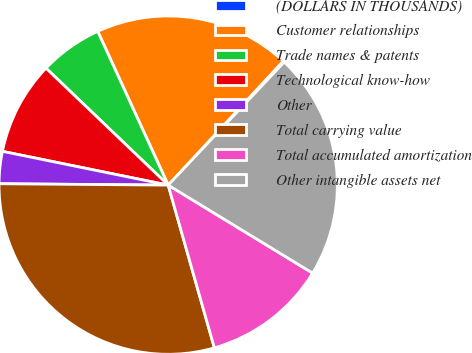Convert chart to OTSL. <chart><loc_0><loc_0><loc_500><loc_500><pie_chart><fcel>(DOLLARS IN THOUSANDS)<fcel>Customer relationships<fcel>Trade names & patents<fcel>Technological know-how<fcel>Other<fcel>Total carrying value<fcel>Total accumulated amortization<fcel>Other intangible assets net<nl><fcel>0.13%<fcel>18.74%<fcel>6.01%<fcel>8.95%<fcel>3.07%<fcel>29.53%<fcel>11.89%<fcel>21.68%<nl></chart> 